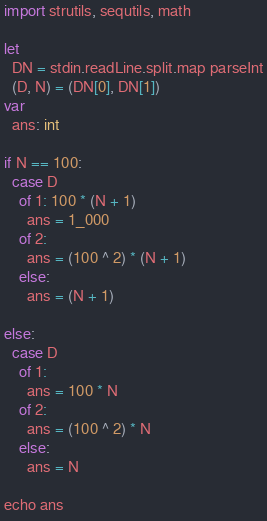<code> <loc_0><loc_0><loc_500><loc_500><_Nim_>import strutils, sequtils, math

let
  DN = stdin.readLine.split.map parseInt
  (D, N) = (DN[0], DN[1])
var
  ans: int

if N == 100:
  case D
    of 1: 100 * (N + 1)
      ans = 1_000
    of 2:
      ans = (100 ^ 2) * (N + 1)
    else:
      ans = (N + 1)

else:
  case D
    of 1:
      ans = 100 * N
    of 2:
      ans = (100 ^ 2) * N
    else:
      ans = N

echo ans
</code> 